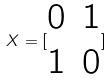Convert formula to latex. <formula><loc_0><loc_0><loc_500><loc_500>X = [ \begin{matrix} 0 & 1 \\ 1 & 0 \end{matrix} ]</formula> 